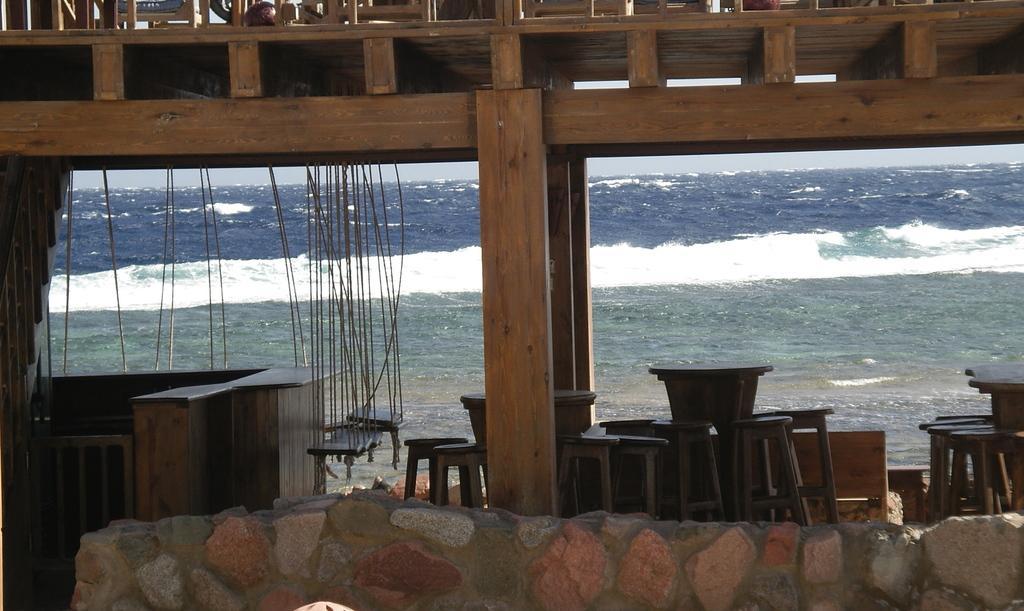How would you summarize this image in a sentence or two? In the foreground of this image, at the bottom, there is a stone wall. In the middle, there are few wooden pillars, tables, stools, swings and the counter desk. In the background, there is water and the sky and it seems like wooden railing at the top. 